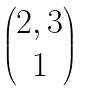Convert formula to latex. <formula><loc_0><loc_0><loc_500><loc_500>\begin{pmatrix} 2 , 3 \\ 1 \end{pmatrix}</formula> 